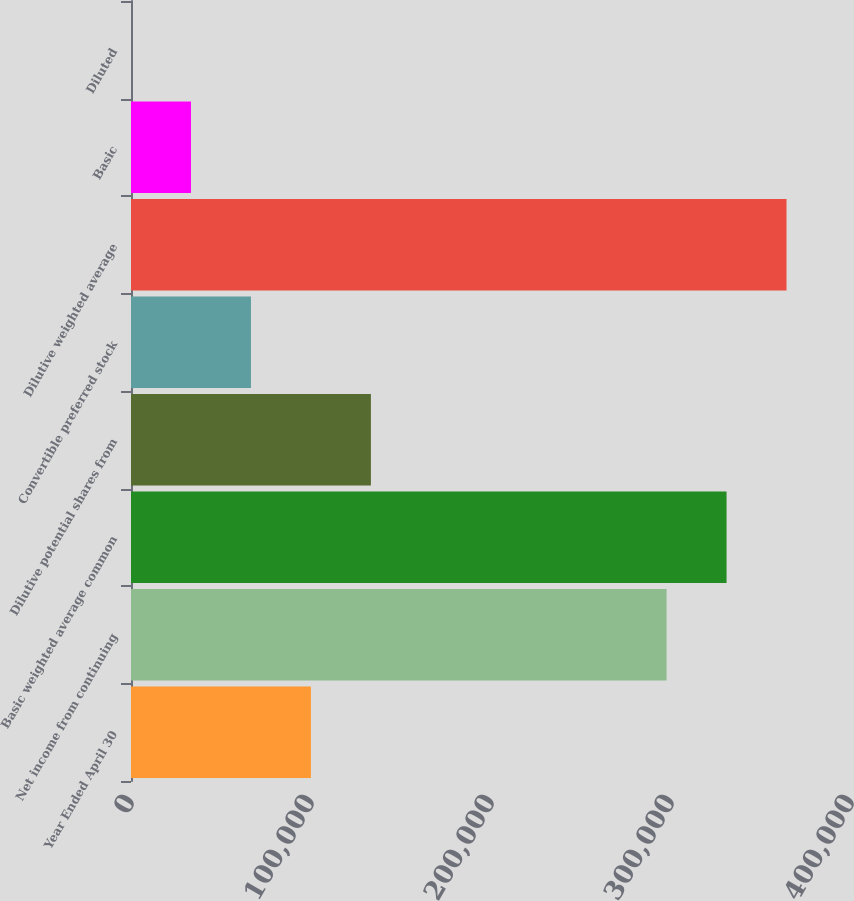<chart> <loc_0><loc_0><loc_500><loc_500><bar_chart><fcel>Year Ended April 30<fcel>Net income from continuing<fcel>Basic weighted average common<fcel>Dilutive potential shares from<fcel>Convertible preferred stock<fcel>Dilutive weighted average<fcel>Basic<fcel>Diluted<nl><fcel>99956.7<fcel>297541<fcel>330860<fcel>133275<fcel>66638.1<fcel>364178<fcel>33319.5<fcel>0.89<nl></chart> 